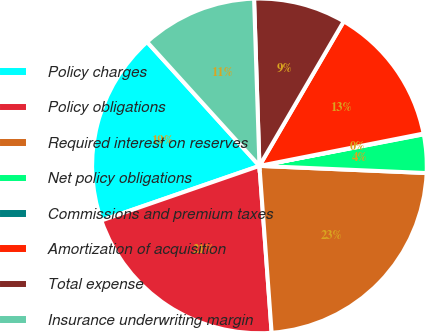<chart> <loc_0><loc_0><loc_500><loc_500><pie_chart><fcel>Policy charges<fcel>Policy obligations<fcel>Required interest on reserves<fcel>Net policy obligations<fcel>Commissions and premium taxes<fcel>Amortization of acquisition<fcel>Total expense<fcel>Insurance underwriting margin<nl><fcel>18.58%<fcel>20.87%<fcel>23.16%<fcel>3.71%<fcel>0.07%<fcel>13.5%<fcel>8.92%<fcel>11.21%<nl></chart> 